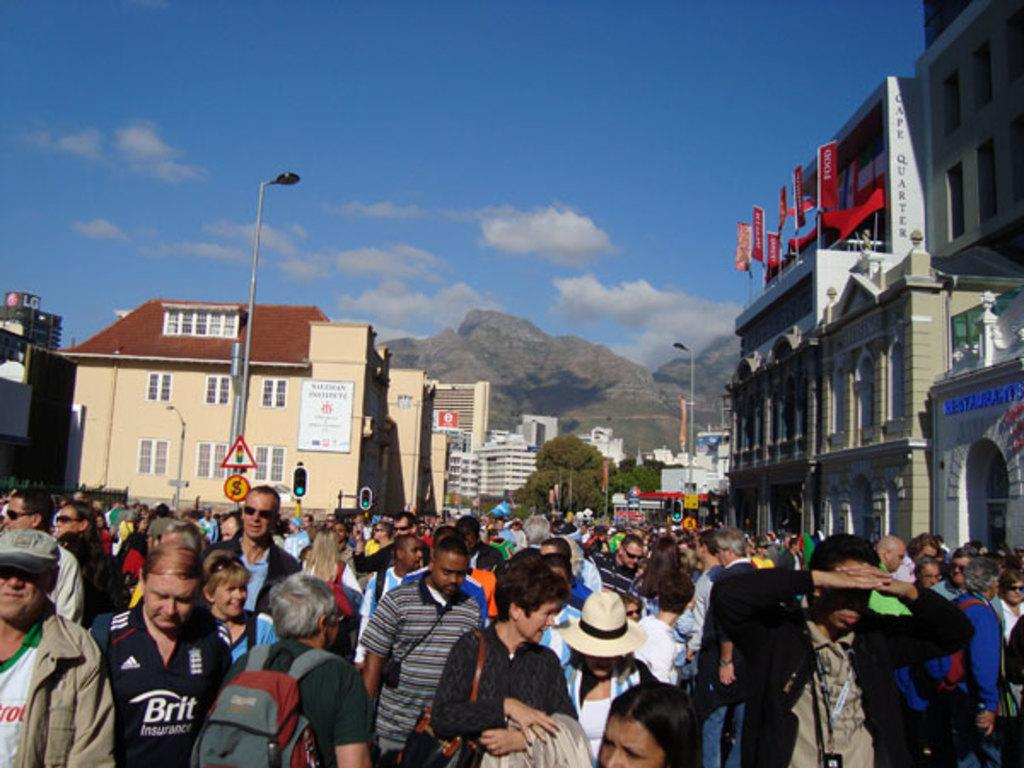What is located at the bottom of the image? There are people at the bottom of the image. What can be seen in the background of the image? There are buildings, mountains, light poles, and the sky visible in the background of the image. What type of instrument is being played by the people at the bottom of the image? There is no instrument being played by the people in the image. Can you see a match being lit in the image? There is no match present in the image. 